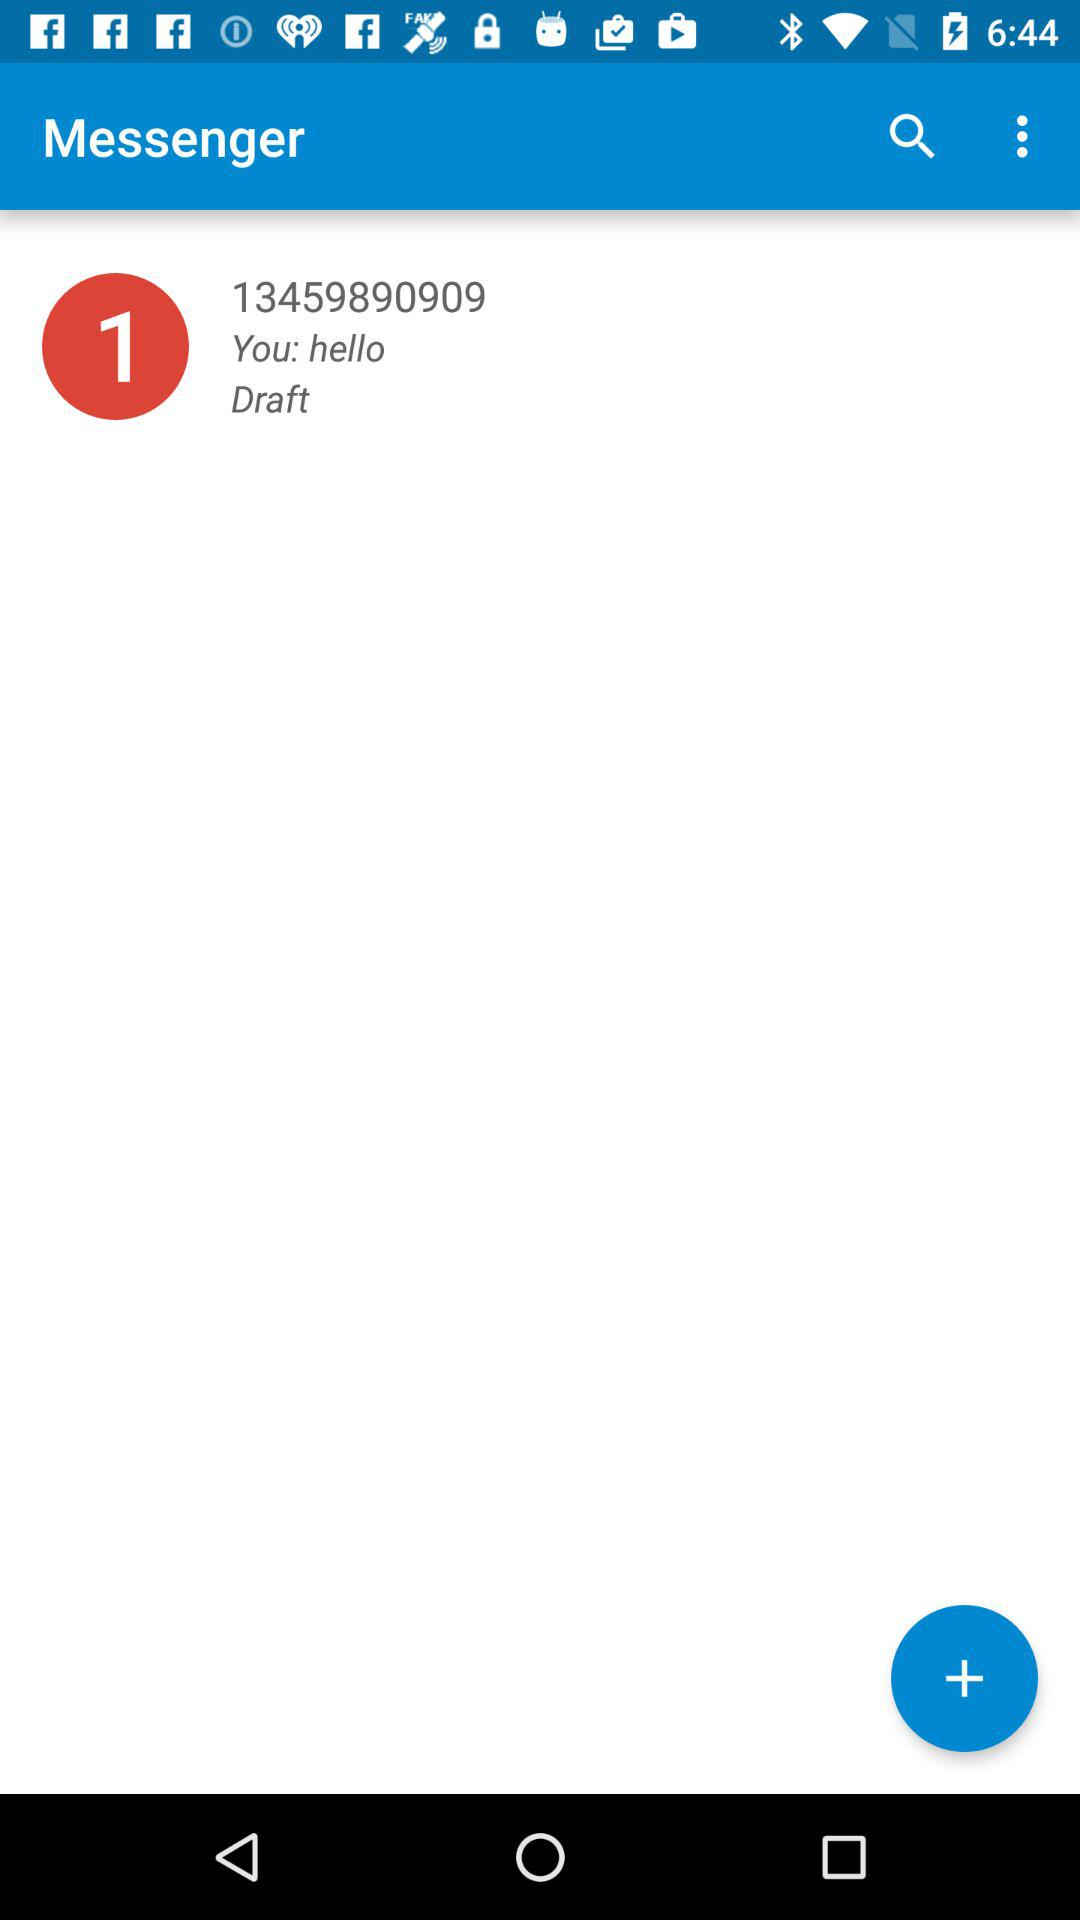What is the name of the application? The name of the application is "Messenger". 